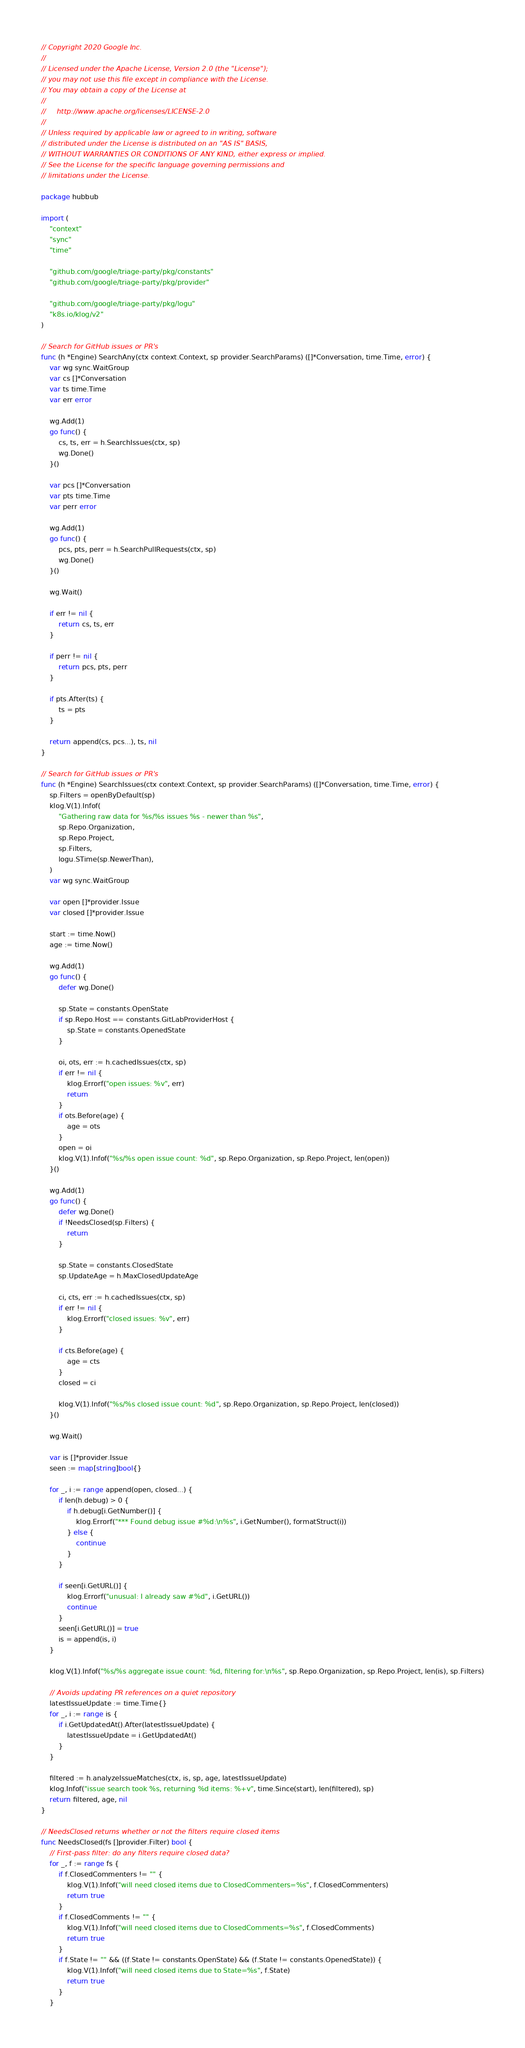Convert code to text. <code><loc_0><loc_0><loc_500><loc_500><_Go_>// Copyright 2020 Google Inc.
//
// Licensed under the Apache License, Version 2.0 (the "License");
// you may not use this file except in compliance with the License.
// You may obtain a copy of the License at
//
//     http://www.apache.org/licenses/LICENSE-2.0
//
// Unless required by applicable law or agreed to in writing, software
// distributed under the License is distributed on an "AS IS" BASIS,
// WITHOUT WARRANTIES OR CONDITIONS OF ANY KIND, either express or implied.
// See the License for the specific language governing permissions and
// limitations under the License.

package hubbub

import (
	"context"
	"sync"
	"time"

	"github.com/google/triage-party/pkg/constants"
	"github.com/google/triage-party/pkg/provider"

	"github.com/google/triage-party/pkg/logu"
	"k8s.io/klog/v2"
)

// Search for GitHub issues or PR's
func (h *Engine) SearchAny(ctx context.Context, sp provider.SearchParams) ([]*Conversation, time.Time, error) {
	var wg sync.WaitGroup
	var cs []*Conversation
	var ts time.Time
	var err error

	wg.Add(1)
	go func() {
		cs, ts, err = h.SearchIssues(ctx, sp)
		wg.Done()
	}()

	var pcs []*Conversation
	var pts time.Time
	var perr error

	wg.Add(1)
	go func() {
		pcs, pts, perr = h.SearchPullRequests(ctx, sp)
		wg.Done()
	}()

	wg.Wait()

	if err != nil {
		return cs, ts, err
	}

	if perr != nil {
		return pcs, pts, perr
	}

	if pts.After(ts) {
		ts = pts
	}

	return append(cs, pcs...), ts, nil
}

// Search for GitHub issues or PR's
func (h *Engine) SearchIssues(ctx context.Context, sp provider.SearchParams) ([]*Conversation, time.Time, error) {
	sp.Filters = openByDefault(sp)
	klog.V(1).Infof(
		"Gathering raw data for %s/%s issues %s - newer than %s",
		sp.Repo.Organization,
		sp.Repo.Project,
		sp.Filters,
		logu.STime(sp.NewerThan),
	)
	var wg sync.WaitGroup

	var open []*provider.Issue
	var closed []*provider.Issue

	start := time.Now()
	age := time.Now()

	wg.Add(1)
	go func() {
		defer wg.Done()

		sp.State = constants.OpenState
		if sp.Repo.Host == constants.GitLabProviderHost {
			sp.State = constants.OpenedState
		}

		oi, ots, err := h.cachedIssues(ctx, sp)
		if err != nil {
			klog.Errorf("open issues: %v", err)
			return
		}
		if ots.Before(age) {
			age = ots
		}
		open = oi
		klog.V(1).Infof("%s/%s open issue count: %d", sp.Repo.Organization, sp.Repo.Project, len(open))
	}()

	wg.Add(1)
	go func() {
		defer wg.Done()
		if !NeedsClosed(sp.Filters) {
			return
		}

		sp.State = constants.ClosedState
		sp.UpdateAge = h.MaxClosedUpdateAge

		ci, cts, err := h.cachedIssues(ctx, sp)
		if err != nil {
			klog.Errorf("closed issues: %v", err)
		}

		if cts.Before(age) {
			age = cts
		}
		closed = ci

		klog.V(1).Infof("%s/%s closed issue count: %d", sp.Repo.Organization, sp.Repo.Project, len(closed))
	}()

	wg.Wait()

	var is []*provider.Issue
	seen := map[string]bool{}

	for _, i := range append(open, closed...) {
		if len(h.debug) > 0 {
			if h.debug[i.GetNumber()] {
				klog.Errorf("*** Found debug issue #%d:\n%s", i.GetNumber(), formatStruct(i))
			} else {
				continue
			}
		}

		if seen[i.GetURL()] {
			klog.Errorf("unusual: I already saw #%d", i.GetURL())
			continue
		}
		seen[i.GetURL()] = true
		is = append(is, i)
	}

	klog.V(1).Infof("%s/%s aggregate issue count: %d, filtering for:\n%s", sp.Repo.Organization, sp.Repo.Project, len(is), sp.Filters)

	// Avoids updating PR references on a quiet repository
	latestIssueUpdate := time.Time{}
	for _, i := range is {
		if i.GetUpdatedAt().After(latestIssueUpdate) {
			latestIssueUpdate = i.GetUpdatedAt()
		}
	}

	filtered := h.analyzeIssueMatches(ctx, is, sp, age, latestIssueUpdate)
	klog.Infof("issue search took %s, returning %d items: %+v", time.Since(start), len(filtered), sp)
	return filtered, age, nil
}

// NeedsClosed returns whether or not the filters require closed items
func NeedsClosed(fs []provider.Filter) bool {
	// First-pass filter: do any filters require closed data?
	for _, f := range fs {
		if f.ClosedCommenters != "" {
			klog.V(1).Infof("will need closed items due to ClosedCommenters=%s", f.ClosedCommenters)
			return true
		}
		if f.ClosedComments != "" {
			klog.V(1).Infof("will need closed items due to ClosedComments=%s", f.ClosedComments)
			return true
		}
		if f.State != "" && ((f.State != constants.OpenState) && (f.State != constants.OpenedState)) {
			klog.V(1).Infof("will need closed items due to State=%s", f.State)
			return true
		}
	}</code> 